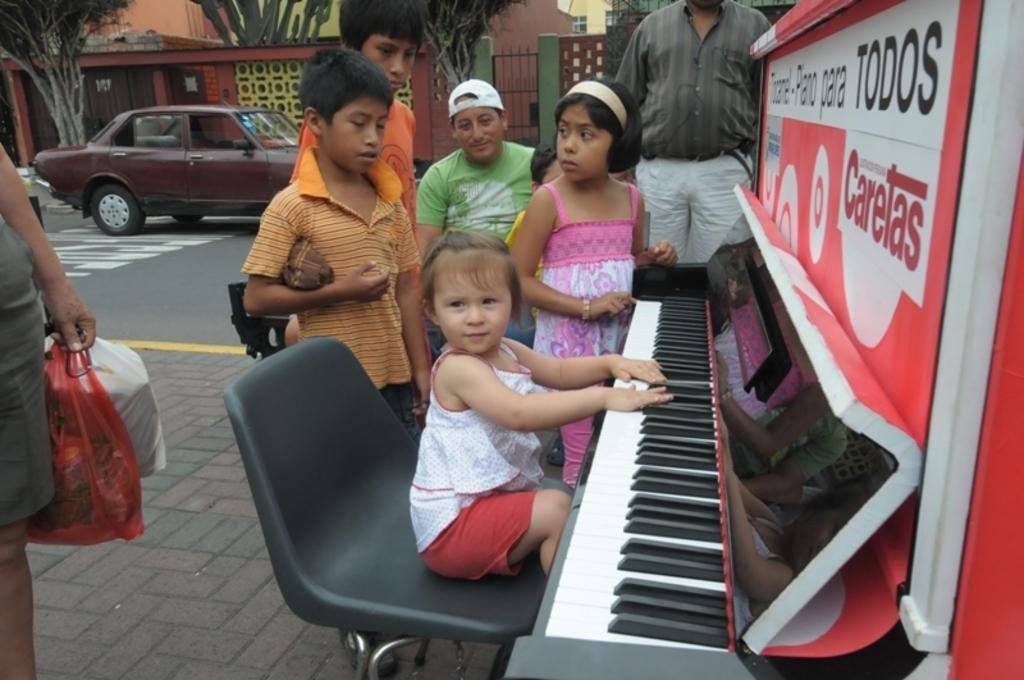Can you describe this image briefly? In the given image we can see a child sitting on chair and she is playing a piano. There are many people looking at her and around her. This is a car. There are trees and buildings around. 